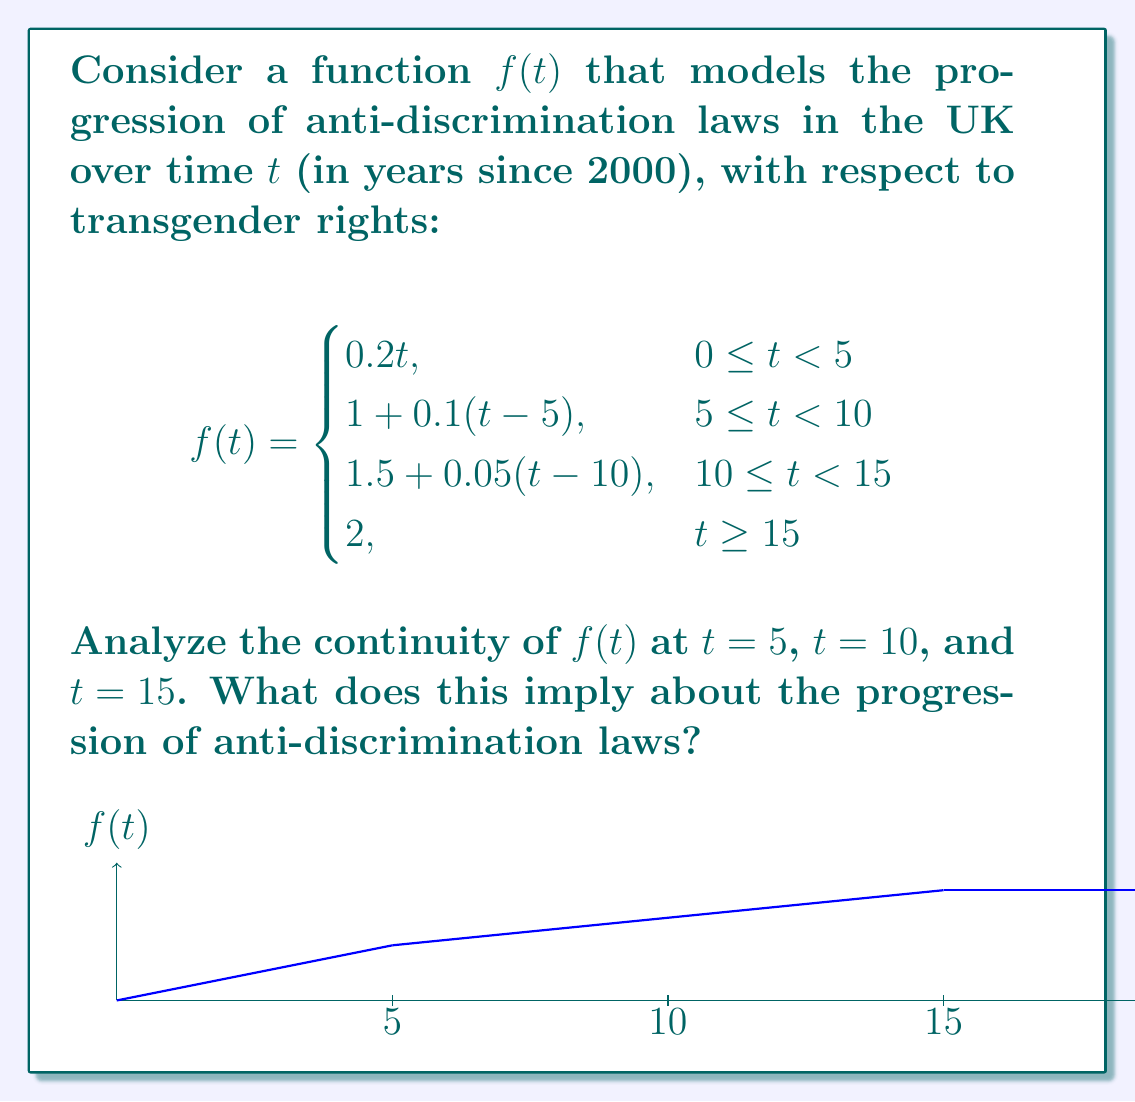Help me with this question. To analyze the continuity of $f(t)$ at $t = 5$, $t = 10$, and $t = 15$, we need to check if the left-hand limit, right-hand limit, and function value are equal at each point.

1. At $t = 5$:
   Left-hand limit: $\lim_{t \to 5^-} f(t) = 0.2 \cdot 5 = 1$
   Right-hand limit: $\lim_{t \to 5^+} f(t) = 1 + 0.1(5-5) = 1$
   Function value: $f(5) = 1$
   All three values are equal, so $f(t)$ is continuous at $t = 5$.

2. At $t = 10$:
   Left-hand limit: $\lim_{t \to 10^-} f(t) = 1 + 0.1(10-5) = 1.5$
   Right-hand limit: $\lim_{t \to 10^+} f(t) = 1.5 + 0.05(10-10) = 1.5$
   Function value: $f(10) = 1.5$
   All three values are equal, so $f(t)$ is continuous at $t = 10$.

3. At $t = 15$:
   Left-hand limit: $\lim_{t \to 15^-} f(t) = 1.5 + 0.05(15-10) = 1.75$
   Right-hand limit: $\lim_{t \to 15^+} f(t) = 2$
   Function value: $f(15) = 2$
   The left-hand limit is not equal to the right-hand limit and function value, so $f(t)$ is not continuous at $t = 15$.

Implications for the progression of anti-discrimination laws:
1. The continuity at $t = 5$ and $t = 10$ suggests smooth transitions in the implementation of anti-discrimination laws at those times.
2. The discontinuity at $t = 15$ implies a sudden change or "jump" in the legal landscape, possibly representing a significant legislative breakthrough for transgender rights.
3. The decreasing slope of each segment indicates a slowing rate of progress over time, possibly due to increasing resistance or complexity in implementing further anti-discrimination measures.
Answer: $f(t)$ is continuous at $t = 5$ and $t = 10$, but discontinuous at $t = 15$, implying smooth transitions in early stages and a sudden significant change after 15 years. 